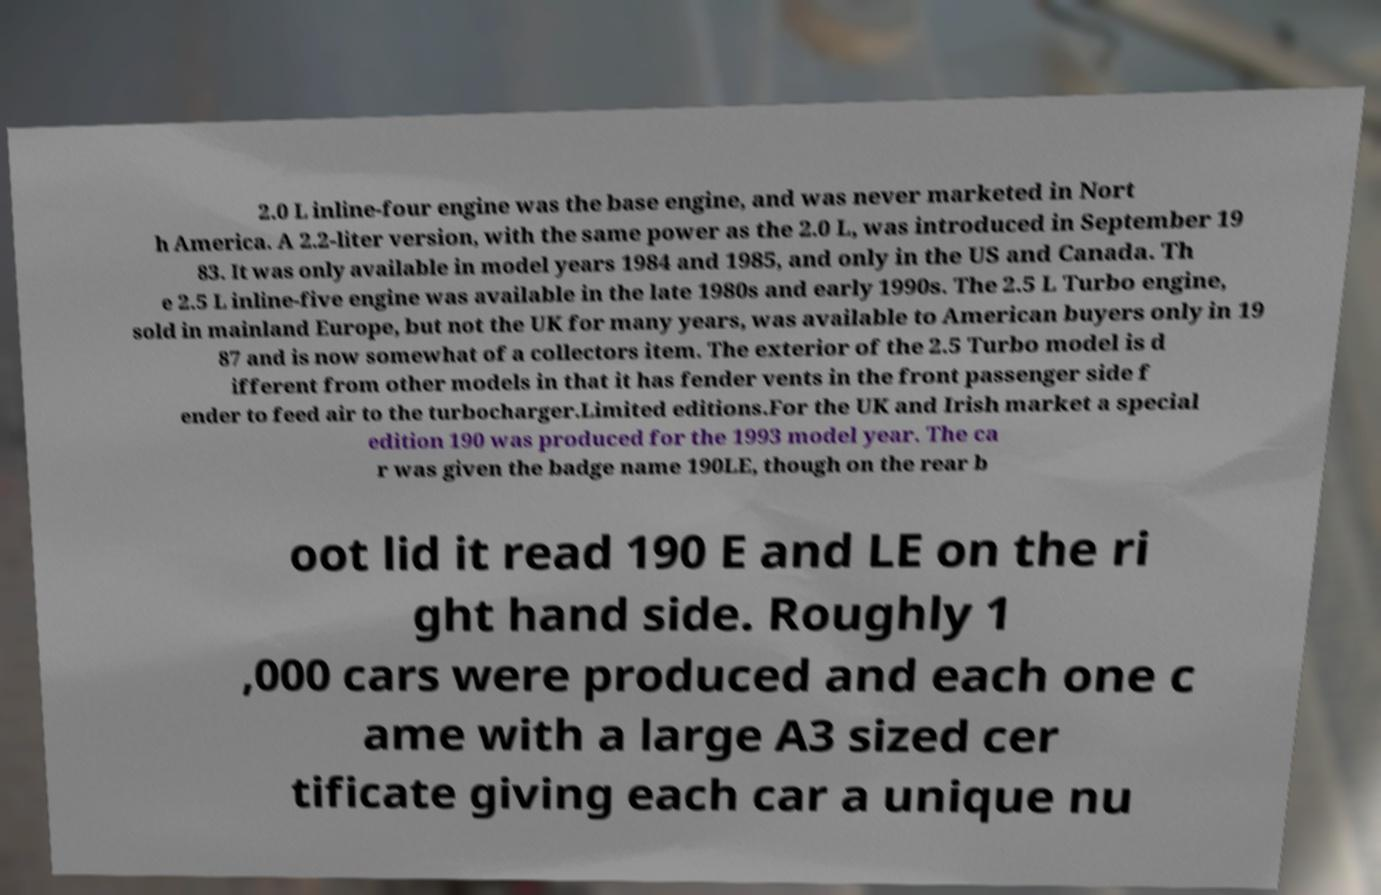Can you accurately transcribe the text from the provided image for me? 2.0 L inline-four engine was the base engine, and was never marketed in Nort h America. A 2.2-liter version, with the same power as the 2.0 L, was introduced in September 19 83. It was only available in model years 1984 and 1985, and only in the US and Canada. Th e 2.5 L inline-five engine was available in the late 1980s and early 1990s. The 2.5 L Turbo engine, sold in mainland Europe, but not the UK for many years, was available to American buyers only in 19 87 and is now somewhat of a collectors item. The exterior of the 2.5 Turbo model is d ifferent from other models in that it has fender vents in the front passenger side f ender to feed air to the turbocharger.Limited editions.For the UK and Irish market a special edition 190 was produced for the 1993 model year. The ca r was given the badge name 190LE, though on the rear b oot lid it read 190 E and LE on the ri ght hand side. Roughly 1 ,000 cars were produced and each one c ame with a large A3 sized cer tificate giving each car a unique nu 